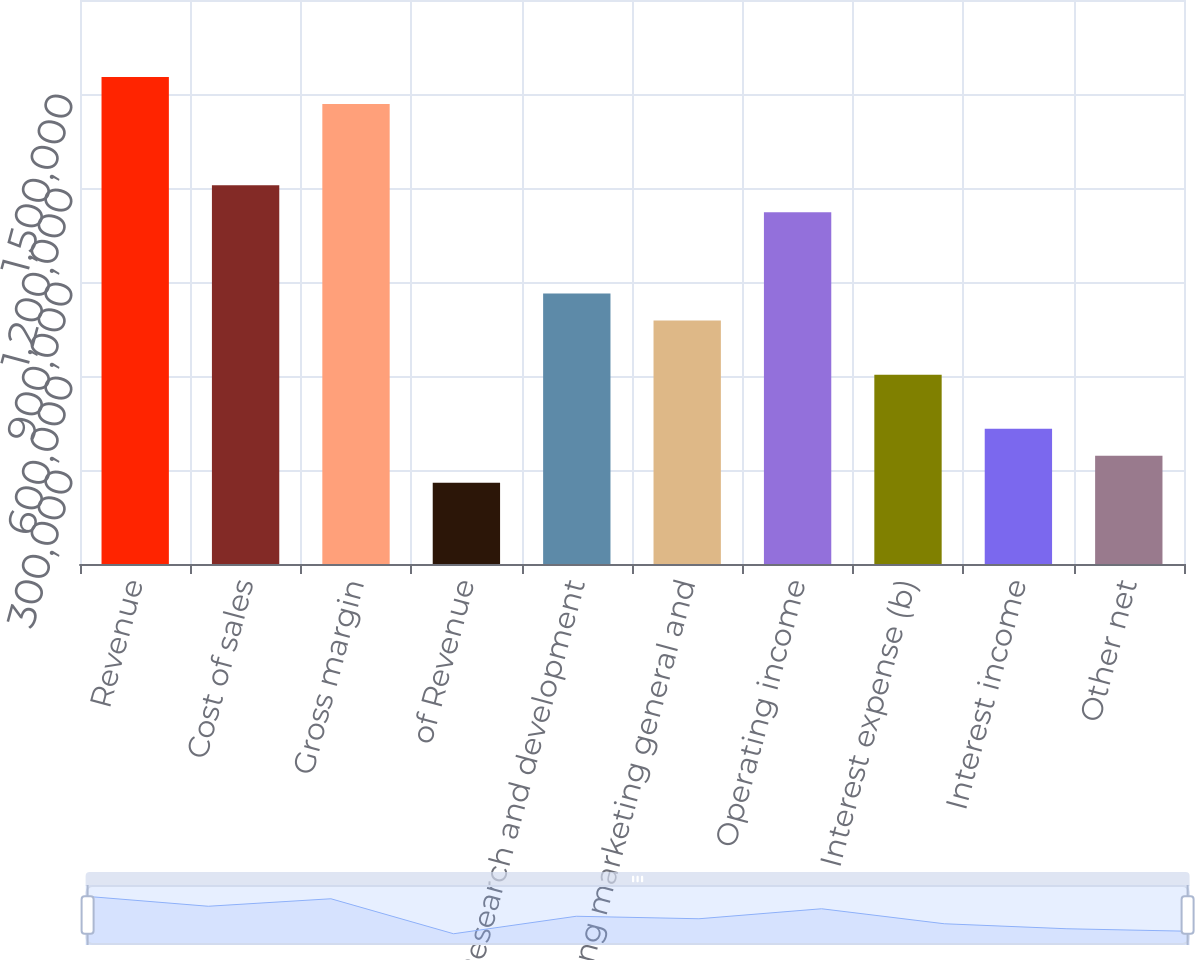<chart> <loc_0><loc_0><loc_500><loc_500><bar_chart><fcel>Revenue<fcel>Cost of sales<fcel>Gross margin<fcel>of Revenue<fcel>Research and development<fcel>Selling marketing general and<fcel>Operating income<fcel>Interest expense (b)<fcel>Interest income<fcel>Other net<nl><fcel>1.55406e+06<fcel>1.20871e+06<fcel>1.46772e+06<fcel>259010<fcel>863365<fcel>777029<fcel>1.12237e+06<fcel>604356<fcel>431683<fcel>345346<nl></chart> 